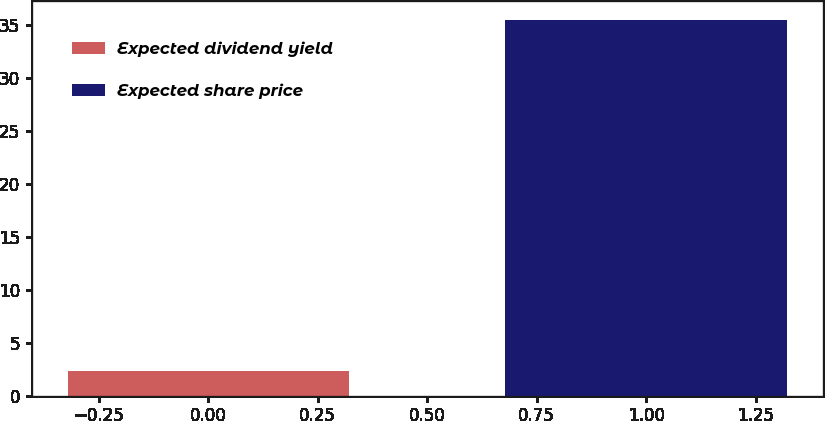Convert chart. <chart><loc_0><loc_0><loc_500><loc_500><bar_chart><fcel>Expected dividend yield<fcel>Expected share price<nl><fcel>2.32<fcel>35.5<nl></chart> 